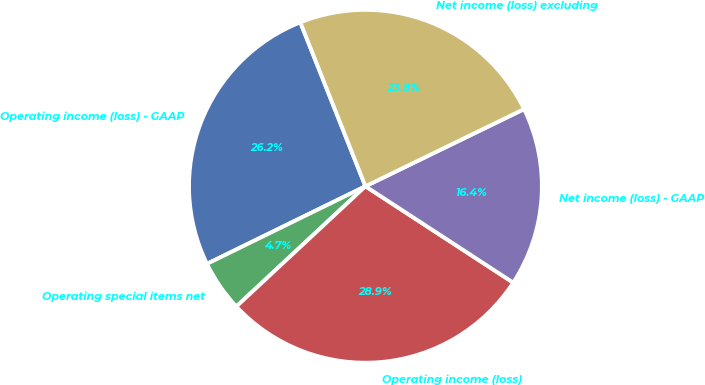Convert chart. <chart><loc_0><loc_0><loc_500><loc_500><pie_chart><fcel>Operating income (loss) - GAAP<fcel>Operating special items net<fcel>Operating income (loss)<fcel>Net income (loss) - GAAP<fcel>Net income (loss) excluding<nl><fcel>26.23%<fcel>4.69%<fcel>28.87%<fcel>16.4%<fcel>23.81%<nl></chart> 